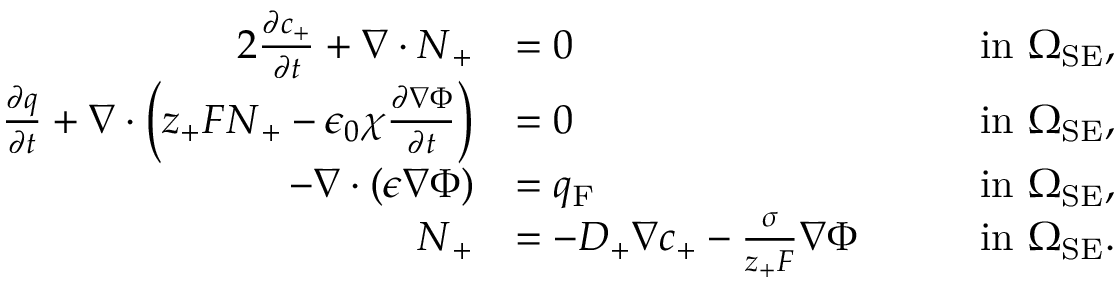Convert formula to latex. <formula><loc_0><loc_0><loc_500><loc_500>\begin{array} { r l r l } { { 2 } \frac { \partial c _ { + } } { \partial t } + \nabla \cdot N _ { + } } & { = 0 } & & { i n \ \Omega _ { S E } , } \\ { \frac { \partial q } { \partial t } + \nabla \cdot \left ( z _ { + } F N _ { + } - \epsilon _ { 0 } \chi \frac { \partial \nabla \Phi } { \partial t } \right ) } & { = 0 } & & { i n \ \Omega _ { S E } , } \\ { - \nabla \cdot ( \epsilon \nabla \Phi ) } & { = q _ { F } } & & { i n \ \Omega _ { S E } , } \\ { N _ { + } } & { = - D _ { + } \nabla c _ { + } - \frac { \sigma } { z _ { + } F } \nabla \Phi \quad } & & { i n \ \Omega _ { S E } . } \end{array}</formula> 